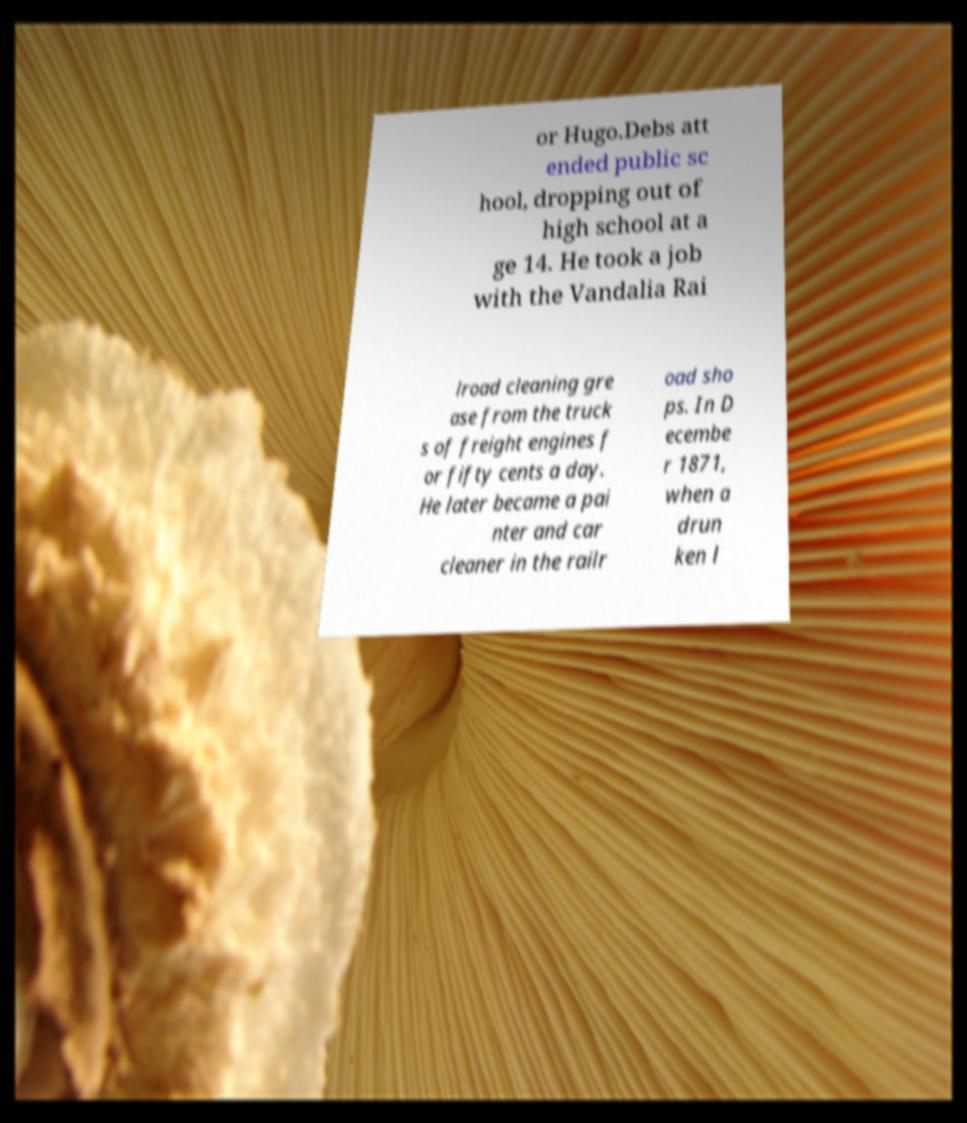There's text embedded in this image that I need extracted. Can you transcribe it verbatim? or Hugo.Debs att ended public sc hool, dropping out of high school at a ge 14. He took a job with the Vandalia Rai lroad cleaning gre ase from the truck s of freight engines f or fifty cents a day. He later became a pai nter and car cleaner in the railr oad sho ps. In D ecembe r 1871, when a drun ken l 